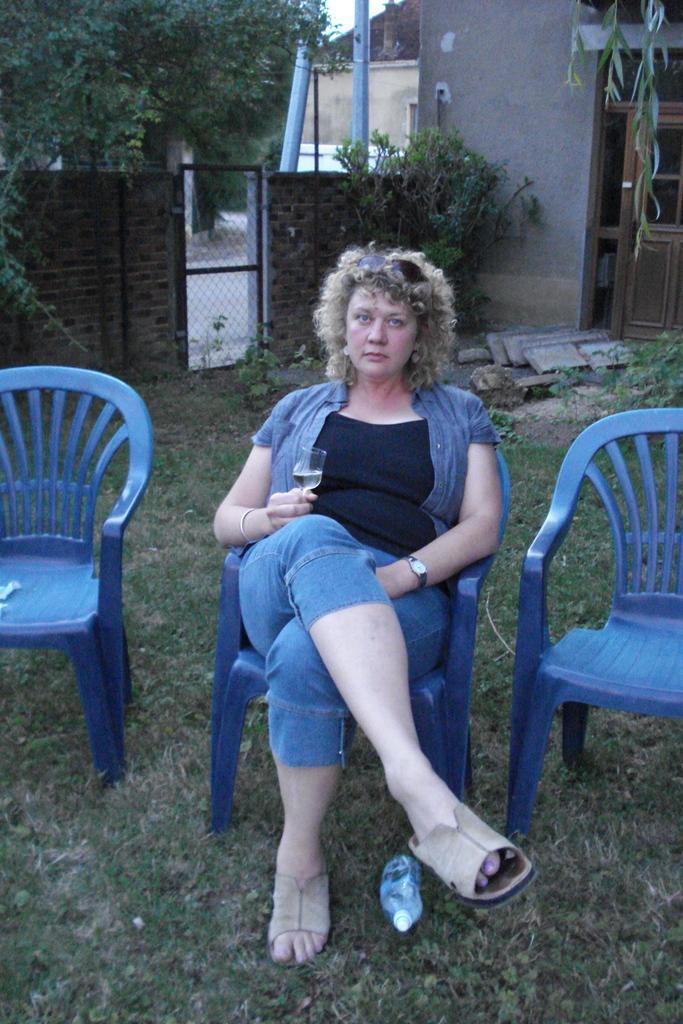Please provide a concise description of this image. In the center of the image we can see a lady sitting and holding a glass. There are chairs. In the background there is a shed, door, wall, gate, trees, pole and sky. At the bottom there is grass and a bottle. 